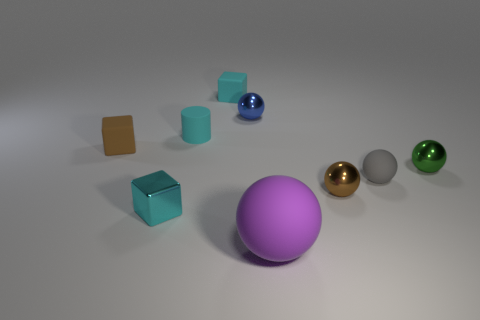Subtract all tiny rubber balls. How many balls are left? 4 Subtract all purple balls. How many balls are left? 4 Subtract all red balls. Subtract all red cylinders. How many balls are left? 5 Subtract all cylinders. How many objects are left? 8 Add 2 tiny matte cylinders. How many tiny matte cylinders exist? 3 Subtract 0 yellow blocks. How many objects are left? 9 Subtract all tiny gray spheres. Subtract all purple things. How many objects are left? 7 Add 6 purple spheres. How many purple spheres are left? 7 